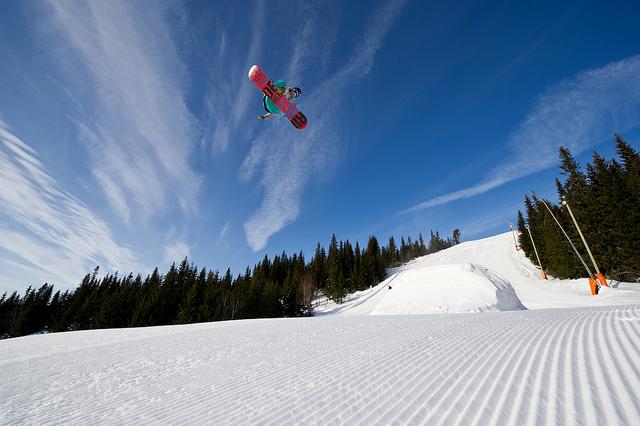What color is the snowboard?
Quick response, please. Red. Is it summer?
Give a very brief answer. No. What activity is this person doing?
Answer briefly. Snowboarding. 